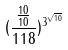Convert formula to latex. <formula><loc_0><loc_0><loc_500><loc_500>( \frac { \frac { 1 0 } { 1 0 } } { 1 1 8 } ) ^ { 3 ^ { \sqrt { 1 0 } } }</formula> 